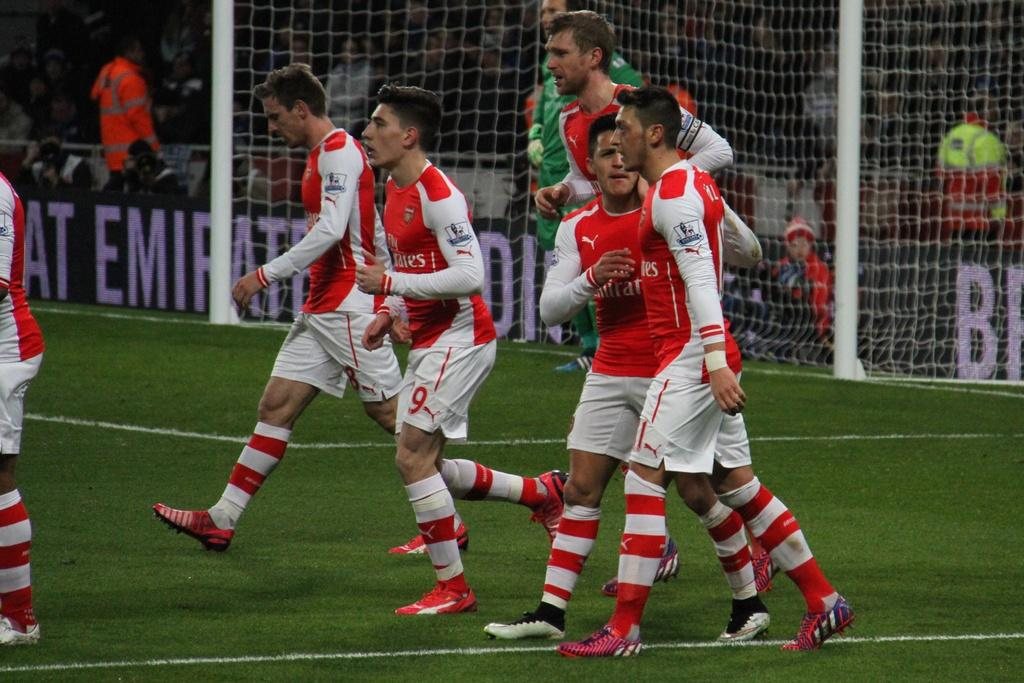Provide a one-sentence caption for the provided image. soccer players in red and white wearing united emerates on their jerseys and that is also on sign on stands. 